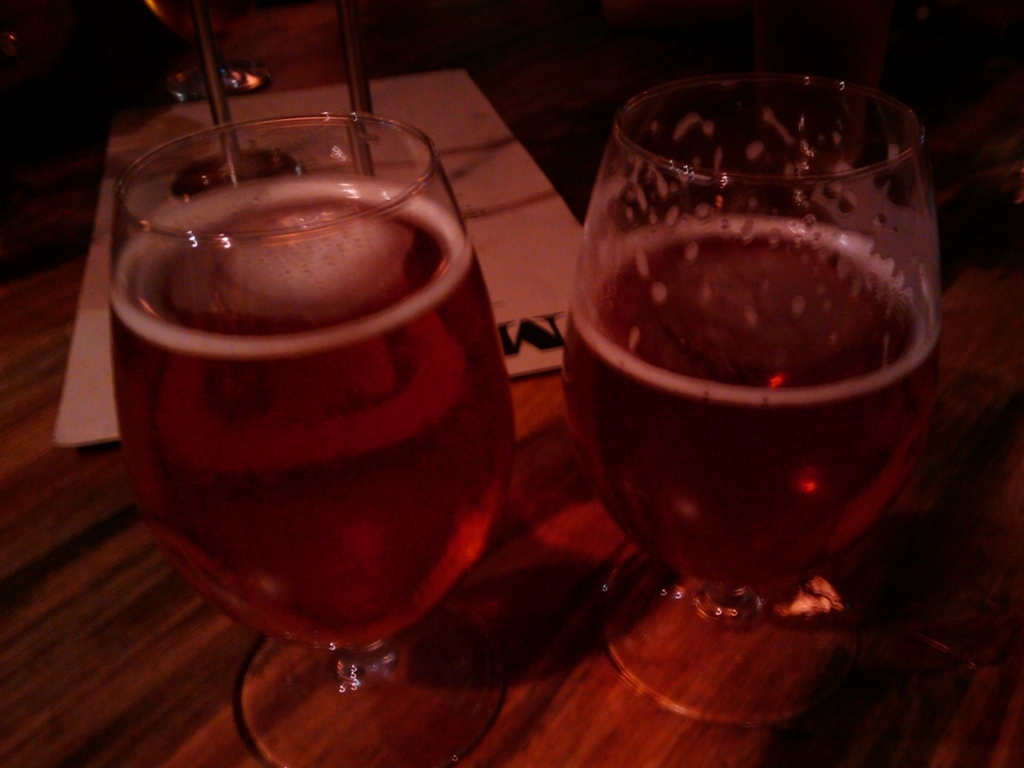Is there any noise or blurring in the image? Yes, there is noticeable noise and blurring present. The image appears to be somewhat grainy, particularly in the darker areas, and the edges of the glasses are not sharp, indicating a slight blurring effect. This may be due to low lighting conditions or movement during the capture process. 